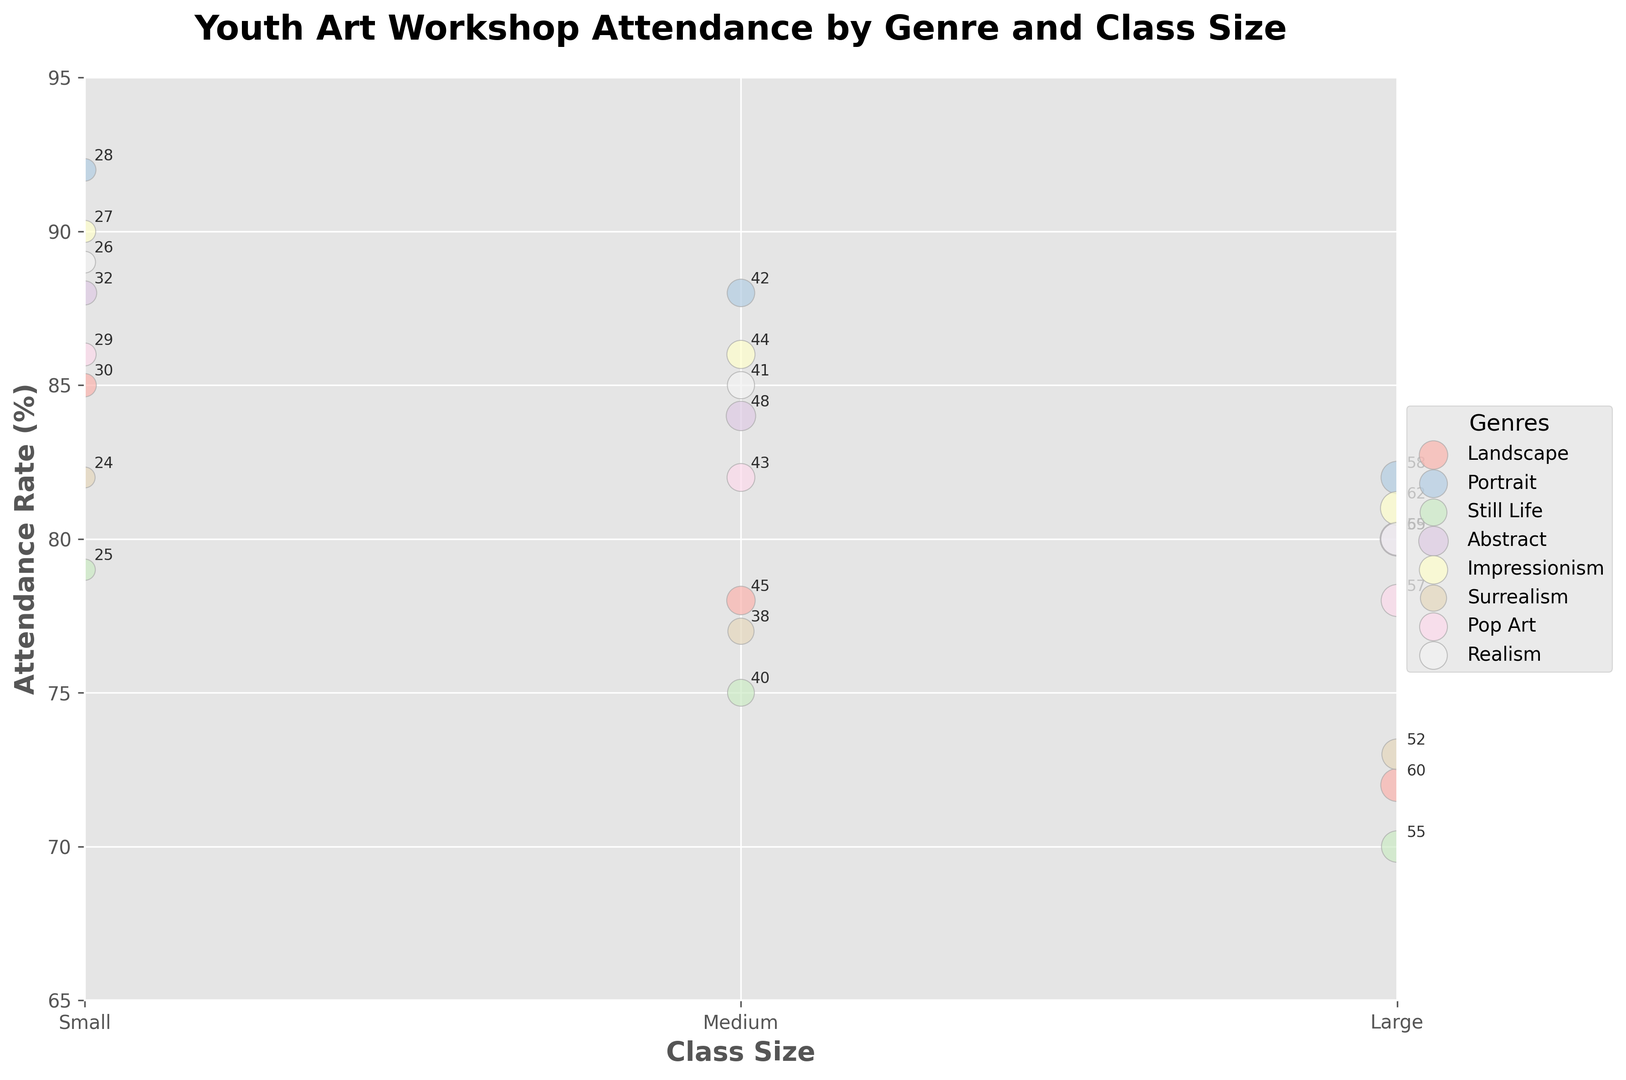Which painting genre had the highest attendance rate for small class sizes? First, identify the genres with small class sizes. The attendance rates are 85, 92, 79, 88, 90, 82, 86, and 89. The highest of these rates is 92, which corresponds to Portrait.
Answer: Portrait Which genre has the largest bubble size for medium class sizes? Bubbles represent the total students. For medium sizes, compare the total students: 45, 42, 40, 48, 44, 38, 43, and 41. The largest value is 48 for Abstract.
Answer: Abstract What's the average attendance rate for large classes across all genres? Identify attendance rates for large classes: 72, 82, 70, 80, 81, 73, 78, and 80. Sum these rates (72+82+70+80+81+73+78+80) to get 616. Then, divide by 8 genres. 616 / 8 = 77
Answer: 77% Which genre has the smallest difference in attendance rates between small and large class sizes? Calculate differences for each genre: Landscape (85-72=13), Portrait (92-82=10), Still Life (79-70=9), Abstract (88-80=8), Impressionism (90-81=9), Surrealism (82-73=9), Pop Art (86-78=8), Realism (89-80=9). The smallest is Abstract and Pop Art with a  difference of 8.
Answer: Abstract and Pop Art Which genre has the lowest attendance rate for any class size? Identify all attendance rates: 85, 78, 72, 92, 88, 82, 79, 75, 70, 88, 84, 80, 90, 86, 81, 82, 77, 73, 86, 82, 78, 89, 85, 80. The lowest rate is 70 for Still Life, large class.
Answer: Still Life (Large) What is the total number of students across all large classes? Sum the total students for large classes: 60, 58, 55, 65, 62, 52, 57, and 59. Total = 60 + 58 + 55 + 65 + 62 + 52 + 57 + 59 = 468
Answer: 468 Which genres have a higher attendance rate for medium-sized classes compared to large-sized classes? Compare medium and large rates: Landscape (78>72), Portrait (88>82), Still Life (75>70), Abstract (84>80), Impressionism (86>81), Surrealism (77>73), Pop Art (82>78), Realism (85>80). All genres have higher rates for medium classes.
Answer: All genres Which genre had a close to identical attendance rate for small and medium class sizes? Compare small and medium rates: Landscape (85, 78), Portrait (92, 88), Still Life (79, 75), Abstract (88, 84), Impressionism (90, 86), Surrealism (82, 77), Pop Art (86, 82), Realism (89, 85). All have different rates, none are identical.
Answer: None Which genre sees the most consistent decline in attendance rates with increasing class sizes? Check the pattern for each genre: Landscape (85, 78, 72), Portrait (92, 88, 82), Still Life (79, 75, 70), Abstract (88, 84, 80), Impressionism (90, 86, 81), Surrealism (82, 77, 73), Pop Art (86, 82, 78), Realism (89, 85, 80). All genres consistently decline as class size increases, so none stand out.
Answer: All genres Which genre has the lowest attendance rate for medium-sized classes? Identify medium rates: 78, 88, 75, 84, 86, 77, 82, and 85. The lowest rate is 75 for Still Life.
Answer: Still Life 